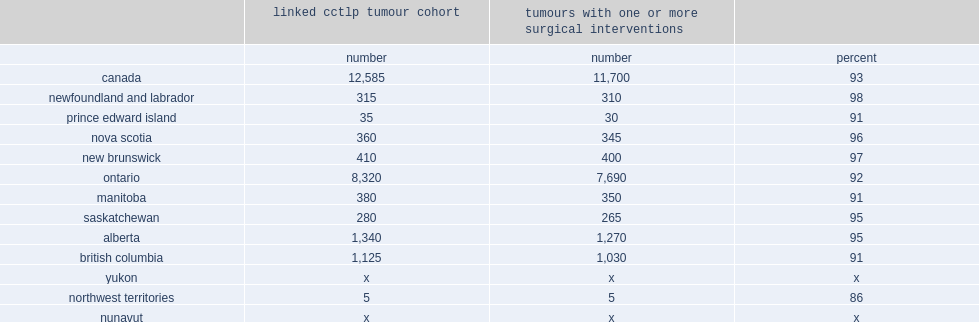Parse the table in full. {'header': ['', 'linked cctlp tumour cohort', 'tumours with one or more surgical interventions', ''], 'rows': [['', 'number', 'number', 'percent'], ['canada', '12,585', '11,700', '93'], ['newfoundland and labrador', '315', '310', '98'], ['prince edward island', '35', '30', '91'], ['nova scotia', '360', '345', '96'], ['new brunswick', '410', '400', '97'], ['ontario', '8,320', '7,690', '92'], ['manitoba', '380', '350', '91'], ['saskatchewan', '280', '265', '95'], ['alberta', '1,340', '1,270', '95'], ['british columbia', '1,125', '1,030', '91'], ['yukon', 'x', 'x', 'x'], ['northwest territories', '5', '5', '86'], ['nunavut', 'x', 'x', 'x']]} What is the overall surgical rate? 93.0. What the provinces where the surgical rate is 91%? Prince edward island manitoba british columbia. What is the surgical rate in newfoundland and labrador? 98.0. 